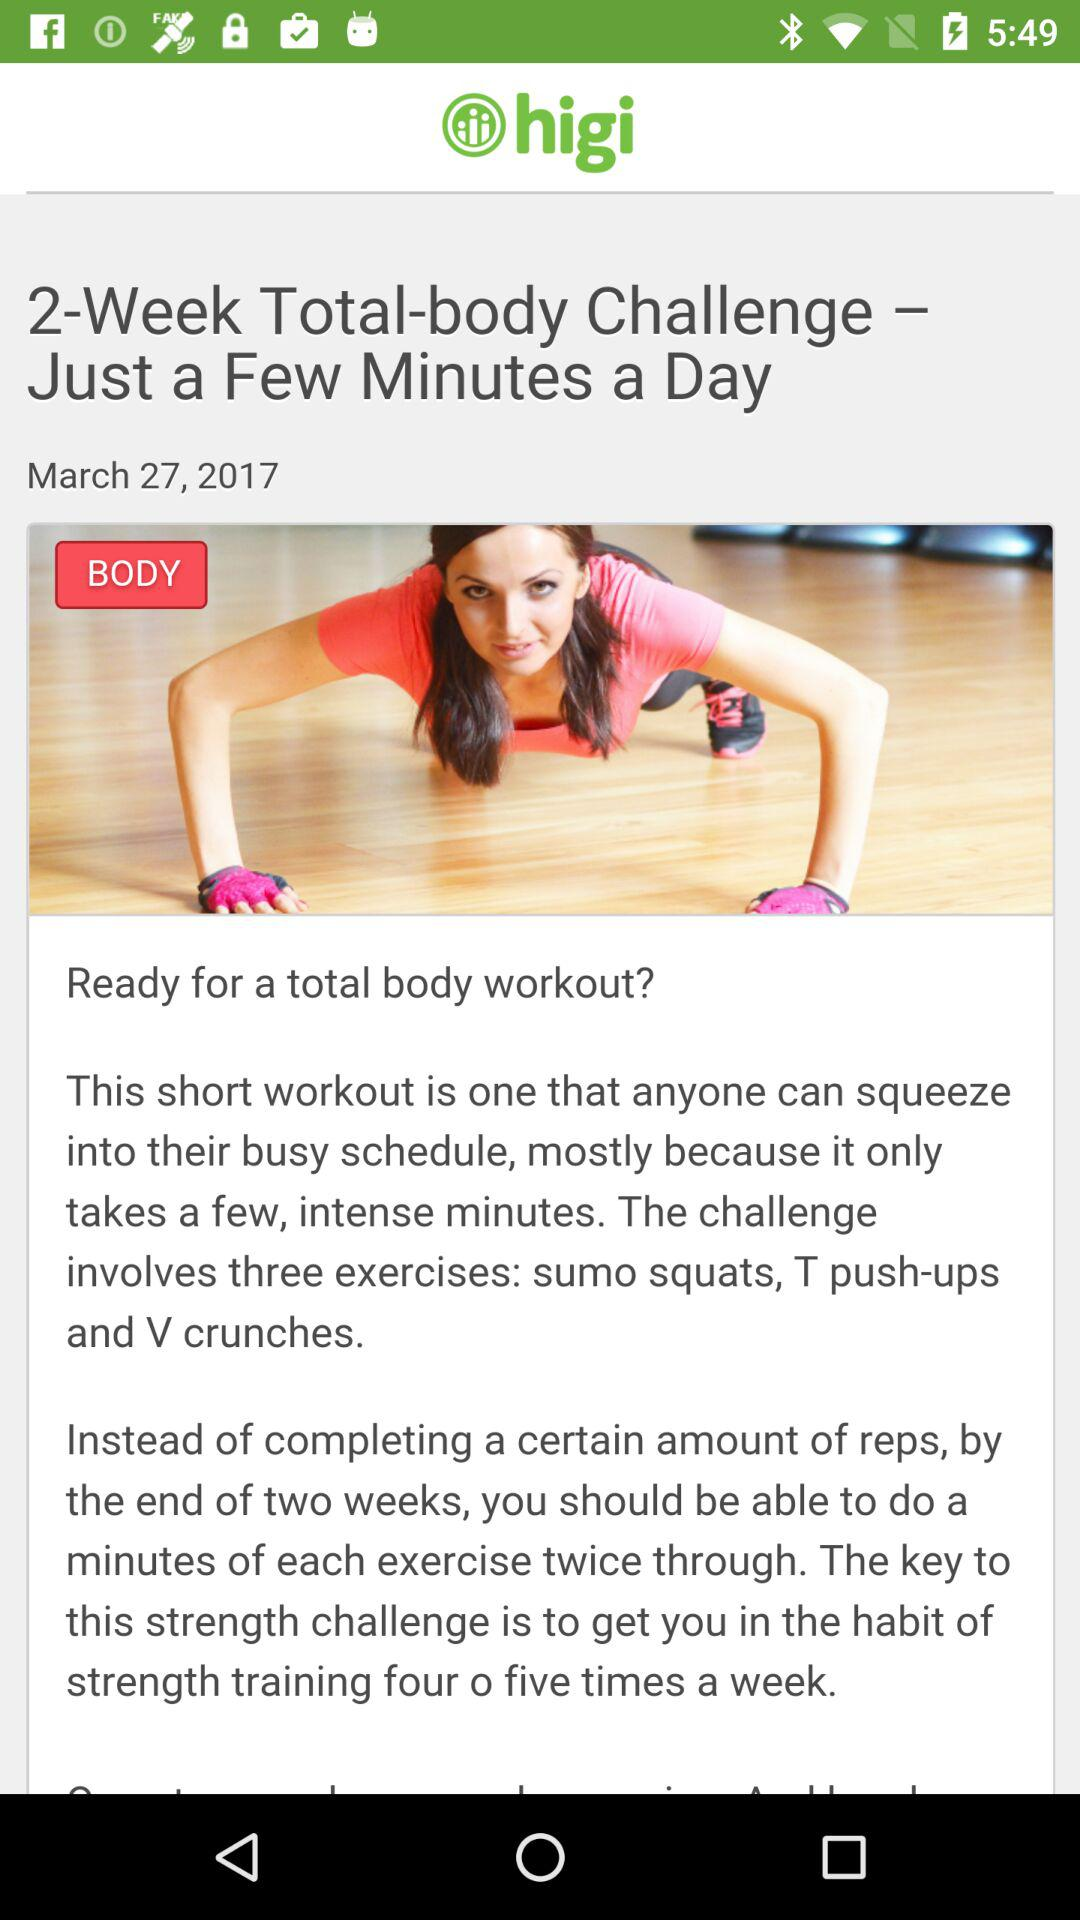When was the article posted? The article was posted on March 27, 2017. 